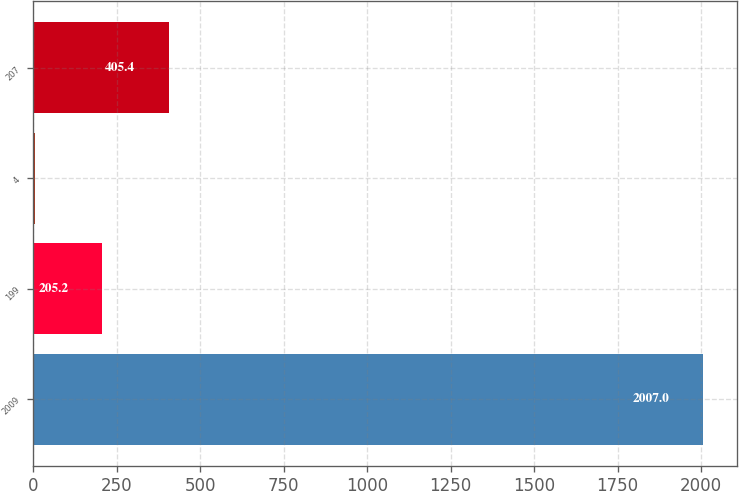<chart> <loc_0><loc_0><loc_500><loc_500><bar_chart><fcel>2009<fcel>199<fcel>4<fcel>207<nl><fcel>2007<fcel>205.2<fcel>5<fcel>405.4<nl></chart> 